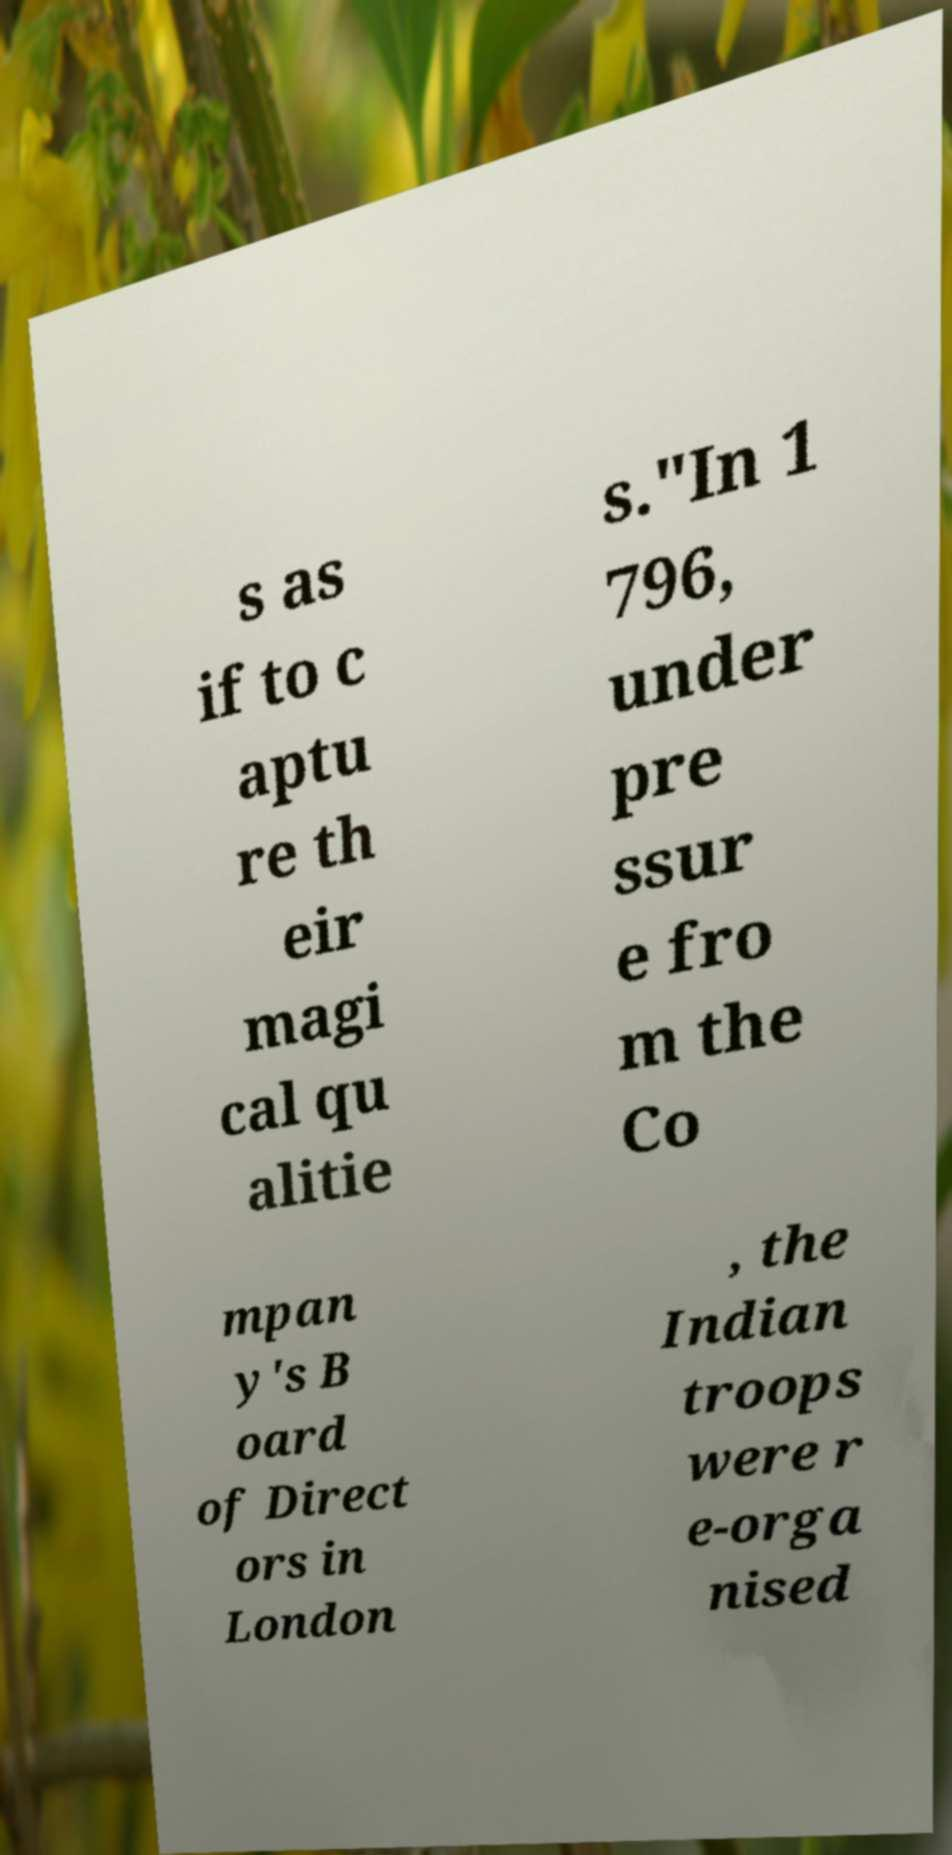What messages or text are displayed in this image? I need them in a readable, typed format. s as if to c aptu re th eir magi cal qu alitie s."In 1 796, under pre ssur e fro m the Co mpan y's B oard of Direct ors in London , the Indian troops were r e-orga nised 